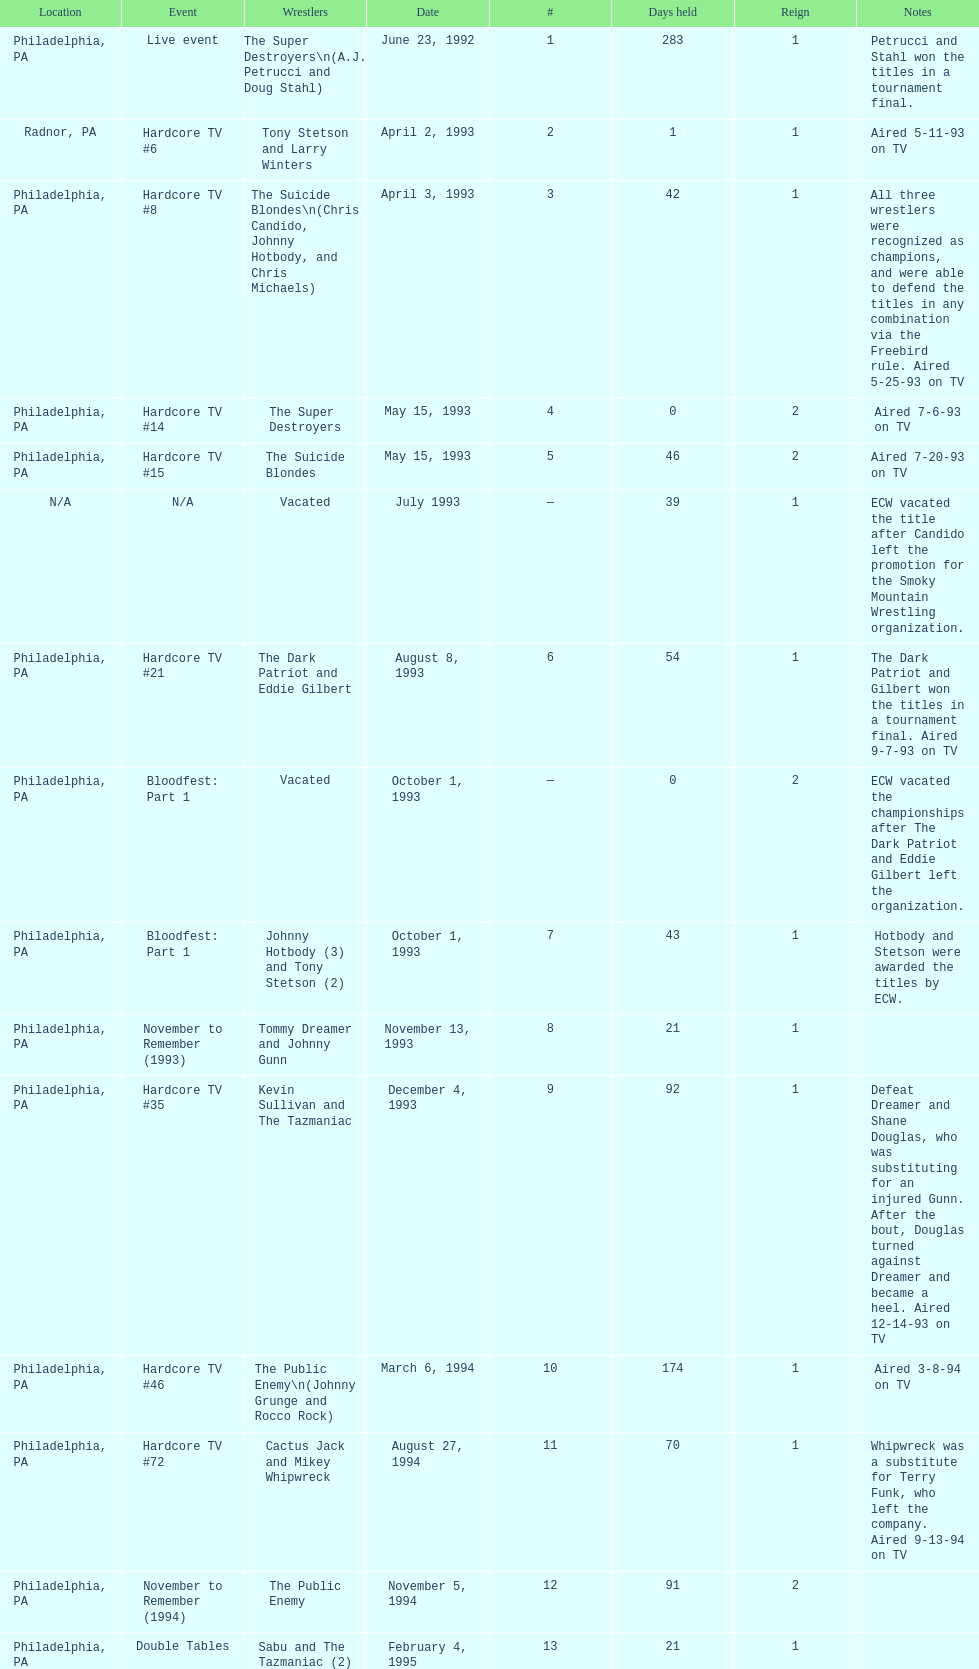Who held the title before the public enemy regained it on april 8th, 1995? Chris Benoit and Dean Malenko. 